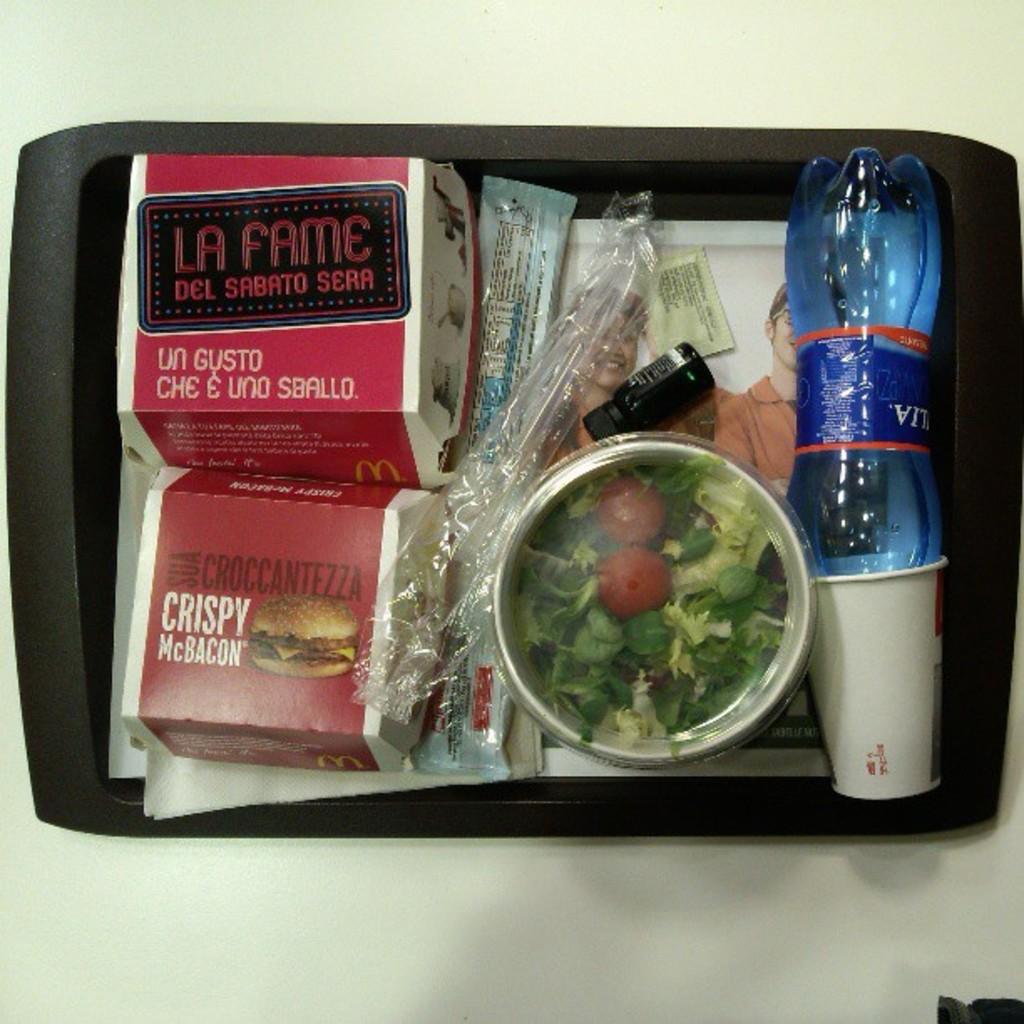What is in the box on the bottom left?
Ensure brevity in your answer.  Crispy mcbacon. What is the name of the sandwich on the bottom left?
Your response must be concise. Crispy mcbacon. 